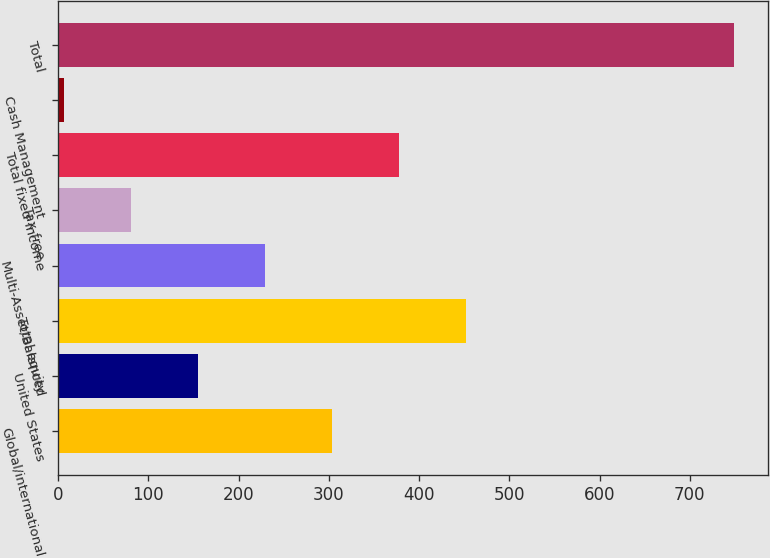<chart> <loc_0><loc_0><loc_500><loc_500><bar_chart><fcel>Global/international<fcel>United States<fcel>Total equity<fcel>Multi-Asset/Balanced<fcel>Tax-free<fcel>Total fixed income<fcel>Cash Management<fcel>Total<nl><fcel>303.62<fcel>155.06<fcel>452.18<fcel>229.34<fcel>80.78<fcel>377.9<fcel>6.5<fcel>749.3<nl></chart> 